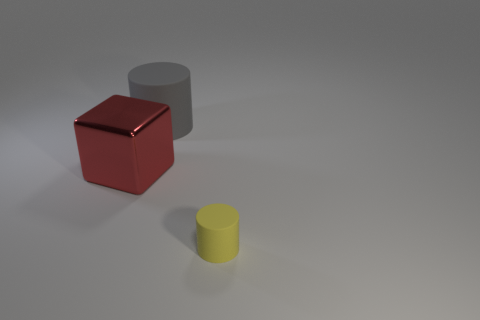Add 1 big red objects. How many objects exist? 4 Subtract all cylinders. How many objects are left? 1 Subtract all gray cylinders. How many cylinders are left? 1 Subtract all blue blocks. How many red cylinders are left? 0 Add 2 big green balls. How many big green balls exist? 2 Subtract 0 green blocks. How many objects are left? 3 Subtract all cyan blocks. Subtract all purple spheres. How many blocks are left? 1 Subtract all yellow rubber cylinders. Subtract all gray matte cylinders. How many objects are left? 1 Add 1 small yellow rubber cylinders. How many small yellow rubber cylinders are left? 2 